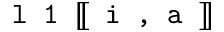<formula> <loc_0><loc_0><loc_500><loc_500>l 1 [ \, [ i , a ] \, ]</formula> 